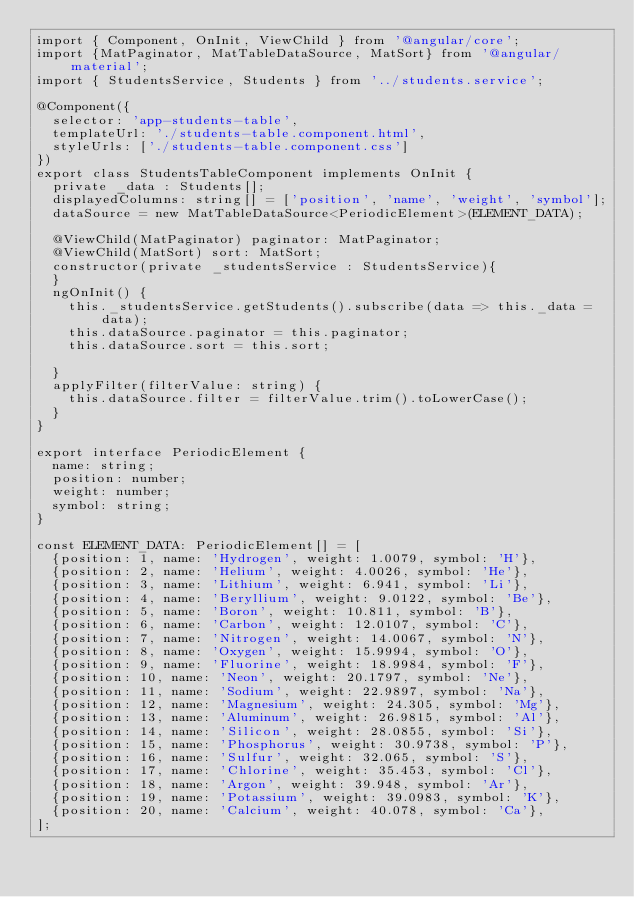Convert code to text. <code><loc_0><loc_0><loc_500><loc_500><_TypeScript_>import { Component, OnInit, ViewChild } from '@angular/core';
import {MatPaginator, MatTableDataSource, MatSort} from '@angular/material';
import { StudentsService, Students } from '../students.service';

@Component({
  selector: 'app-students-table',
  templateUrl: './students-table.component.html',
  styleUrls: ['./students-table.component.css']
})
export class StudentsTableComponent implements OnInit {
  private _data : Students[];
  displayedColumns: string[] = ['position', 'name', 'weight', 'symbol'];
  dataSource = new MatTableDataSource<PeriodicElement>(ELEMENT_DATA);

  @ViewChild(MatPaginator) paginator: MatPaginator;
  @ViewChild(MatSort) sort: MatSort;
  constructor(private _studentsService : StudentsService){
  }
  ngOnInit() {
    this._studentsService.getStudents().subscribe(data => this._data = data);
    this.dataSource.paginator = this.paginator;
    this.dataSource.sort = this.sort;

  }
  applyFilter(filterValue: string) {
    this.dataSource.filter = filterValue.trim().toLowerCase();
  }
}

export interface PeriodicElement {
  name: string;
  position: number;
  weight: number;
  symbol: string;
}

const ELEMENT_DATA: PeriodicElement[] = [
  {position: 1, name: 'Hydrogen', weight: 1.0079, symbol: 'H'},
  {position: 2, name: 'Helium', weight: 4.0026, symbol: 'He'},
  {position: 3, name: 'Lithium', weight: 6.941, symbol: 'Li'},
  {position: 4, name: 'Beryllium', weight: 9.0122, symbol: 'Be'},
  {position: 5, name: 'Boron', weight: 10.811, symbol: 'B'},
  {position: 6, name: 'Carbon', weight: 12.0107, symbol: 'C'},
  {position: 7, name: 'Nitrogen', weight: 14.0067, symbol: 'N'},
  {position: 8, name: 'Oxygen', weight: 15.9994, symbol: 'O'},
  {position: 9, name: 'Fluorine', weight: 18.9984, symbol: 'F'},
  {position: 10, name: 'Neon', weight: 20.1797, symbol: 'Ne'},
  {position: 11, name: 'Sodium', weight: 22.9897, symbol: 'Na'},
  {position: 12, name: 'Magnesium', weight: 24.305, symbol: 'Mg'},
  {position: 13, name: 'Aluminum', weight: 26.9815, symbol: 'Al'},
  {position: 14, name: 'Silicon', weight: 28.0855, symbol: 'Si'},
  {position: 15, name: 'Phosphorus', weight: 30.9738, symbol: 'P'},
  {position: 16, name: 'Sulfur', weight: 32.065, symbol: 'S'},
  {position: 17, name: 'Chlorine', weight: 35.453, symbol: 'Cl'},
  {position: 18, name: 'Argon', weight: 39.948, symbol: 'Ar'},
  {position: 19, name: 'Potassium', weight: 39.0983, symbol: 'K'},
  {position: 20, name: 'Calcium', weight: 40.078, symbol: 'Ca'},
];
</code> 